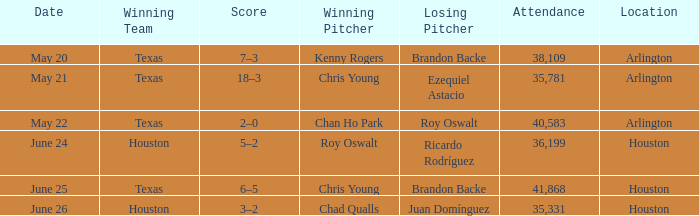Which location has a date of may 21? Arlington. 